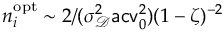Convert formula to latex. <formula><loc_0><loc_0><loc_500><loc_500>n _ { i } ^ { o p t } \sim 2 / ( \sigma _ { \ m a t h s c r D } ^ { 2 } a c v _ { 0 } ^ { 2 } ) ( 1 - \zeta ) ^ { - 2 }</formula> 